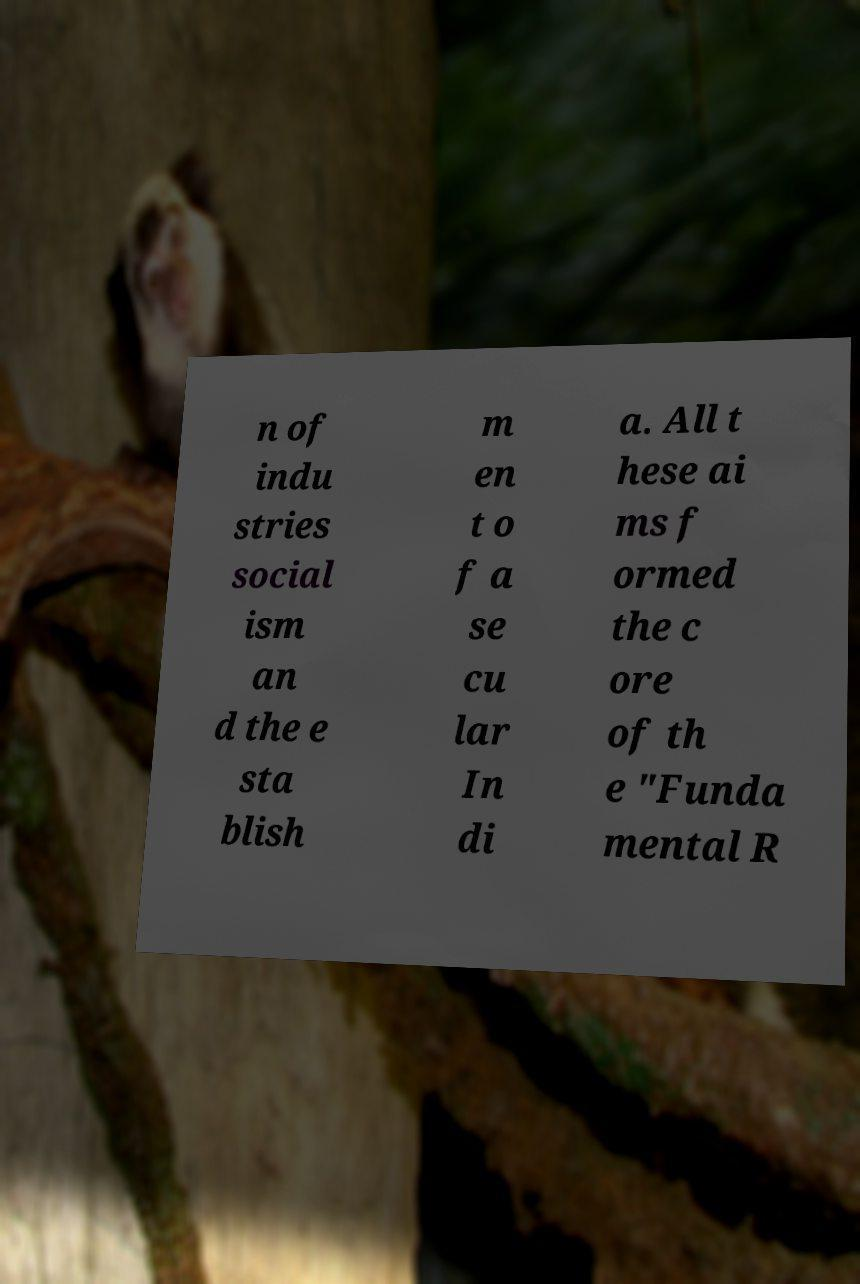Please read and relay the text visible in this image. What does it say? n of indu stries social ism an d the e sta blish m en t o f a se cu lar In di a. All t hese ai ms f ormed the c ore of th e "Funda mental R 